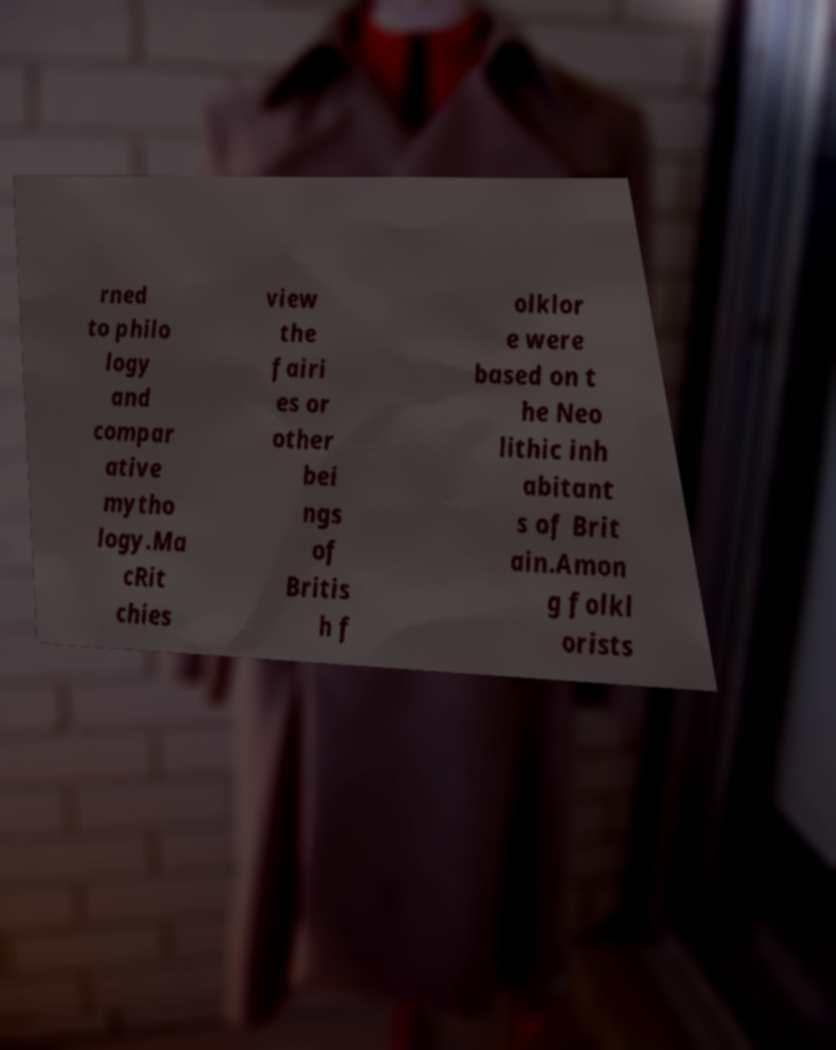Could you assist in decoding the text presented in this image and type it out clearly? rned to philo logy and compar ative mytho logy.Ma cRit chies view the fairi es or other bei ngs of Britis h f olklor e were based on t he Neo lithic inh abitant s of Brit ain.Amon g folkl orists 